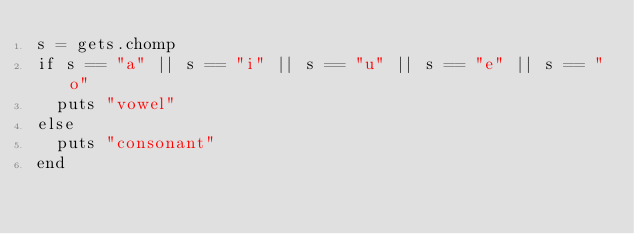Convert code to text. <code><loc_0><loc_0><loc_500><loc_500><_Ruby_>s = gets.chomp
if s == "a" || s == "i" || s == "u" || s == "e" || s == "o"
  puts "vowel"
else
  puts "consonant"
end</code> 